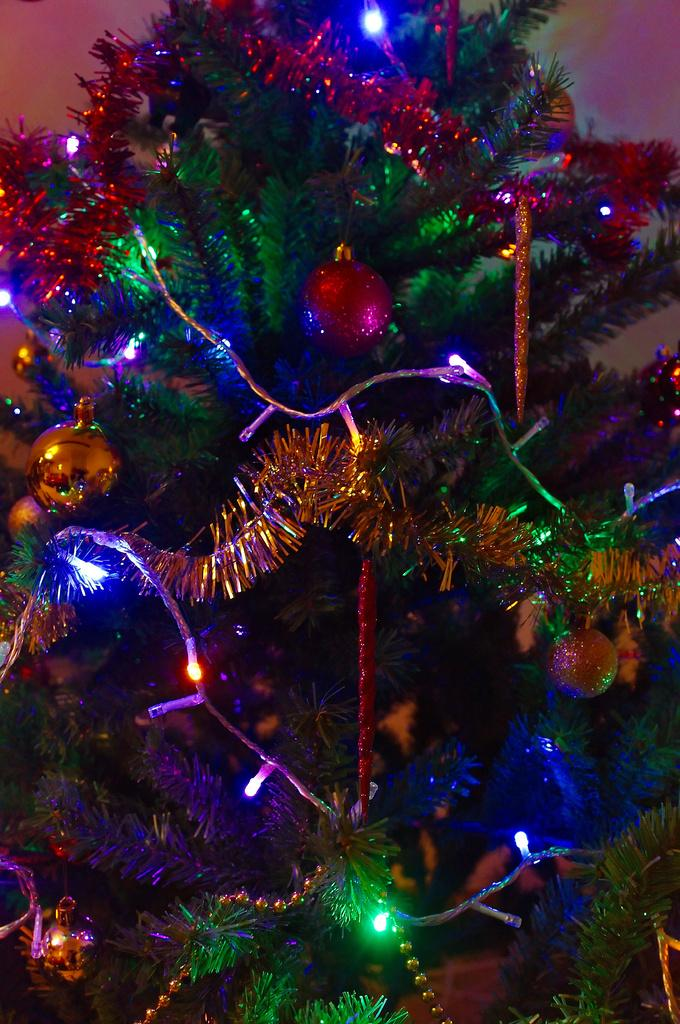What type of tree is in the picture? There is an artificial tree in the picture. How is the tree decorated? The tree is decorated with balls, lights, and other decorative items. What type of stew is being served on the tree? There is no stew present in the image; it features an artificial tree decorated with balls, lights, and other decorative items. What type of pen is used to write on the tree? There is no pen or writing on the tree in the image. 